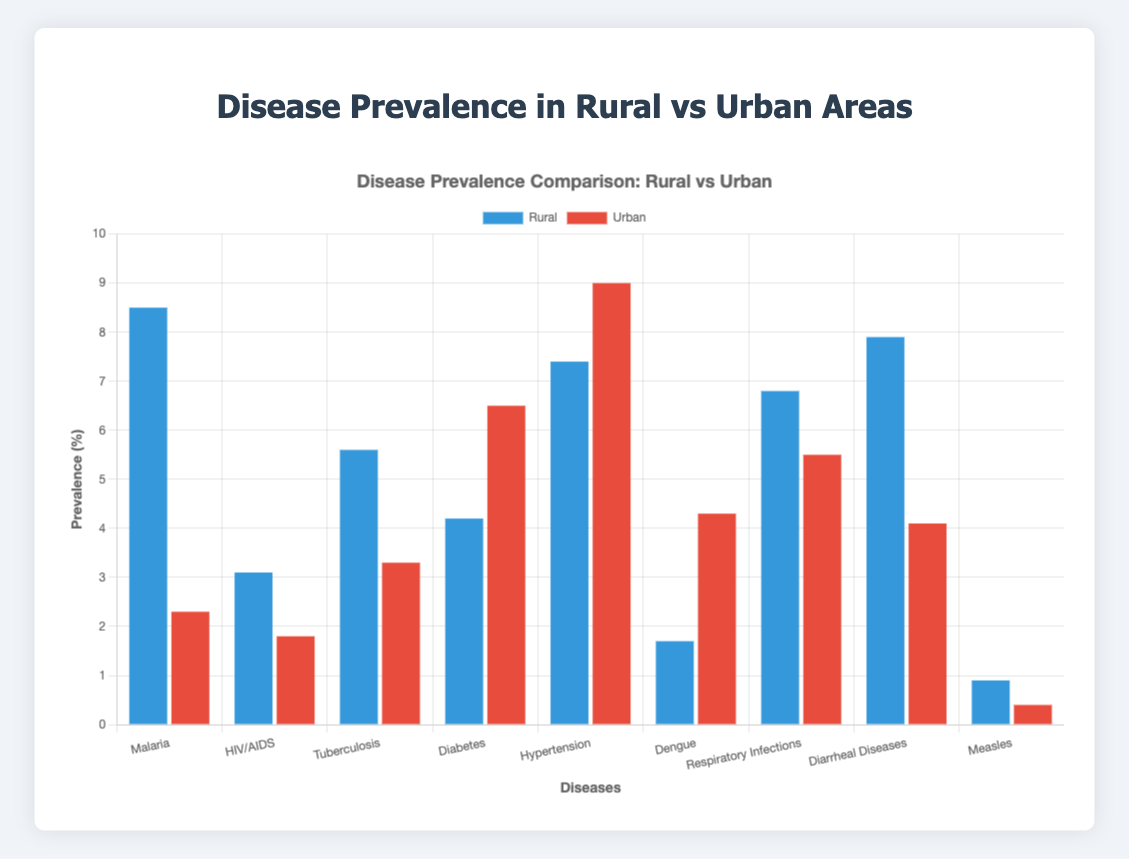Which disease has the highest prevalence in rural areas? The bar representing Malaria in rural areas is the tallest in the chart when compared to other diseases within the rural area section, indicating the highest prevalence.
Answer: Malaria Which disease has the highest prevalence in urban areas? The bar representing Hypertension in urban areas is the tallest in the chart when compared to other diseases within the urban area section, indicating the highest prevalence.
Answer: Hypertension Which disease shows the largest difference in prevalence between rural and urban areas? To find this, we need to look at the bars for each disease in both rural and urban sections. Malaria has the most significant difference, with a prevalence of 8.5% in rural areas and 2.3% in urban areas. Calculating the difference: 8.5 - 2.3 = 6.2.
Answer: Malaria Compare the prevalence of Diabetes in rural and urban areas. Looking at the bars for Diabetes, the rural area has a prevalence of 4.2%, and the urban area has a prevalence of 6.5%. This shows that Diabetes is more prevalent in urban areas.
Answer: Urban areas have higher prevalence Which disease has a higher prevalence in rural areas than in urban areas? By comparing the bars of each disease in both sections, we see that Malaria, HIV/AIDS, Tuberculosis, Diarrheal Diseases, and Respiratory Infections have higher prevalence rates in rural areas.
Answer: Malaria, HIV/AIDS, Tuberculosis, Diarrheal Diseases, Respiratory Infections What is the average prevalence of HIV/AIDS in both rural and urban areas? Adding the prevalence values for HIV/AIDS in rural and urban areas: 3.1 + 1.8 = 4.9. Then, dividing the sum by 2 to find the average: 4.9 / 2 = 2.45.
Answer: 2.45 How does the prevalence of Dengue in urban areas compare to that in rural areas? The prevalence of Dengue in urban areas is represented by a higher bar, with a value of 4.3%, than in rural areas which have a prevalence of 1.7%. This shows a higher prevalence in urban areas.
Answer: Higher in urban areas What is the total prevalence of Respiratory Infections across both rural and urban areas? Adding the prevalence rates of Respiratory Infections in both areas: 6.8 (rural) + 5.5 (urban) = 12.3.
Answer: 12.3 Which location has a higher overall prevalence of chronic diseases like Diabetes and Hypertension? Adding the prevalence rates of Diabetes and Hypertension for rural: 4.2 + 7.4 = 11.6, and for urban: 6.5 + 9.0 = 15.5. Urban areas have higher combined prevalences for these chronic diseases.
Answer: Urban areas What is the median prevalence of diseases in rural areas? Listing rural prevalences: 0.9, 1.7, 3.1, 4.2, 5.6, 6.8, 7.4, 7.9, 8.5. The median is the middle value, which is the 5th value in this sorted list: 5.6.
Answer: 5.6 